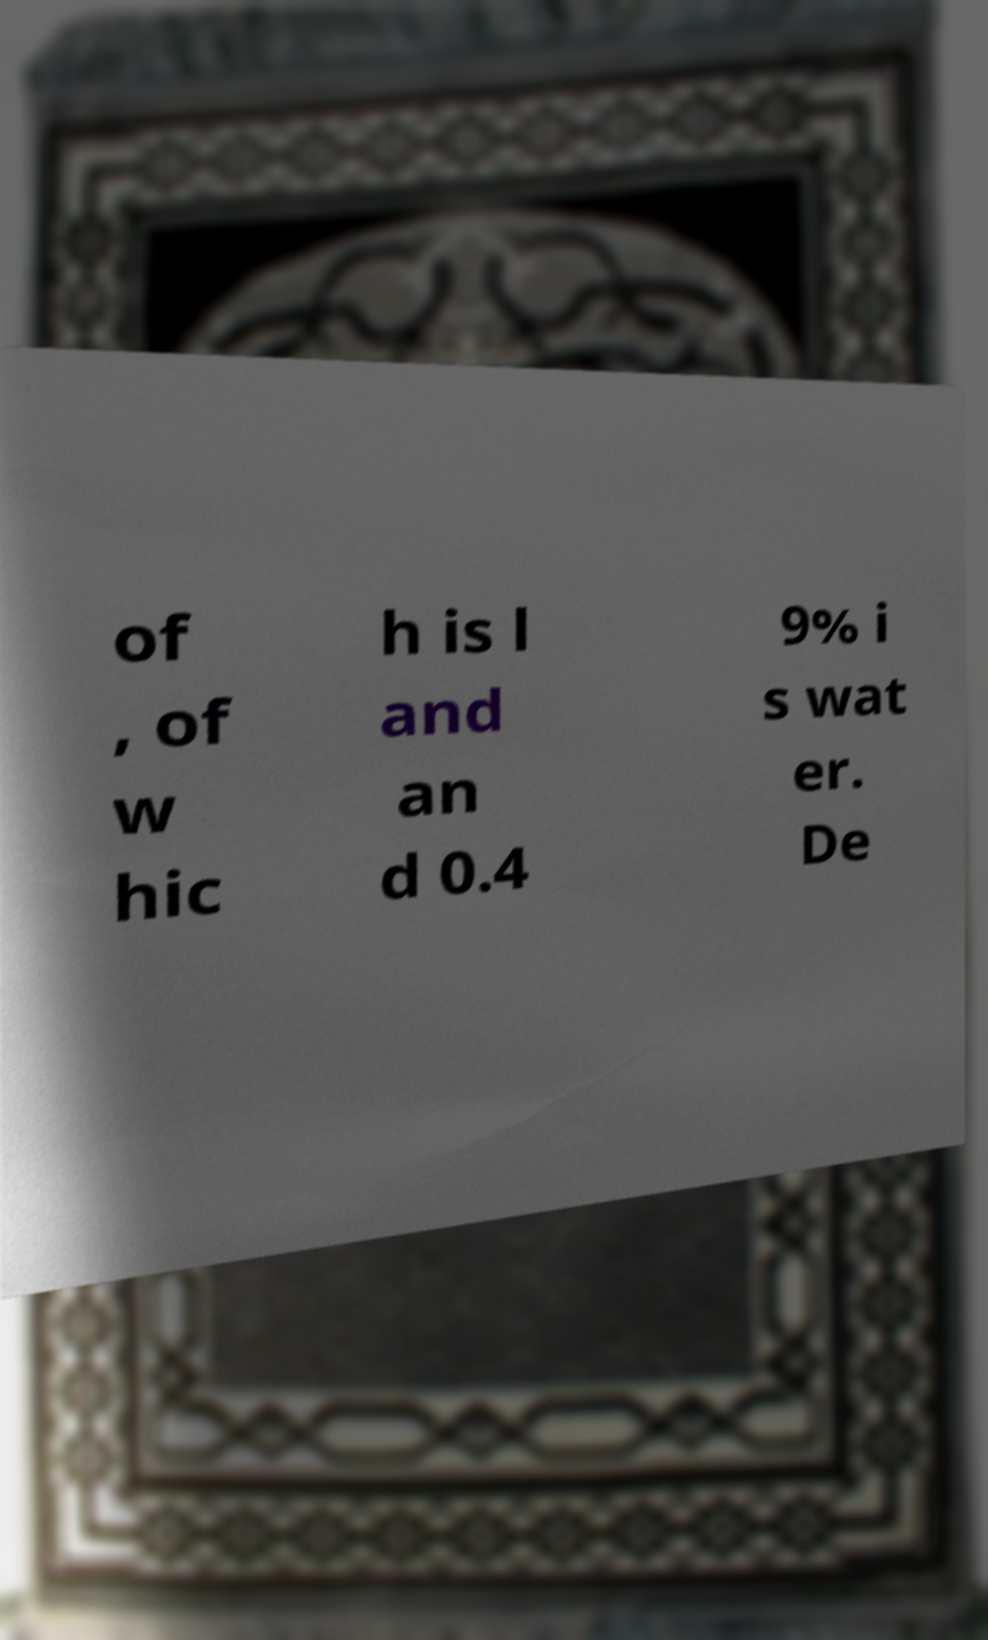Can you accurately transcribe the text from the provided image for me? of , of w hic h is l and an d 0.4 9% i s wat er. De 